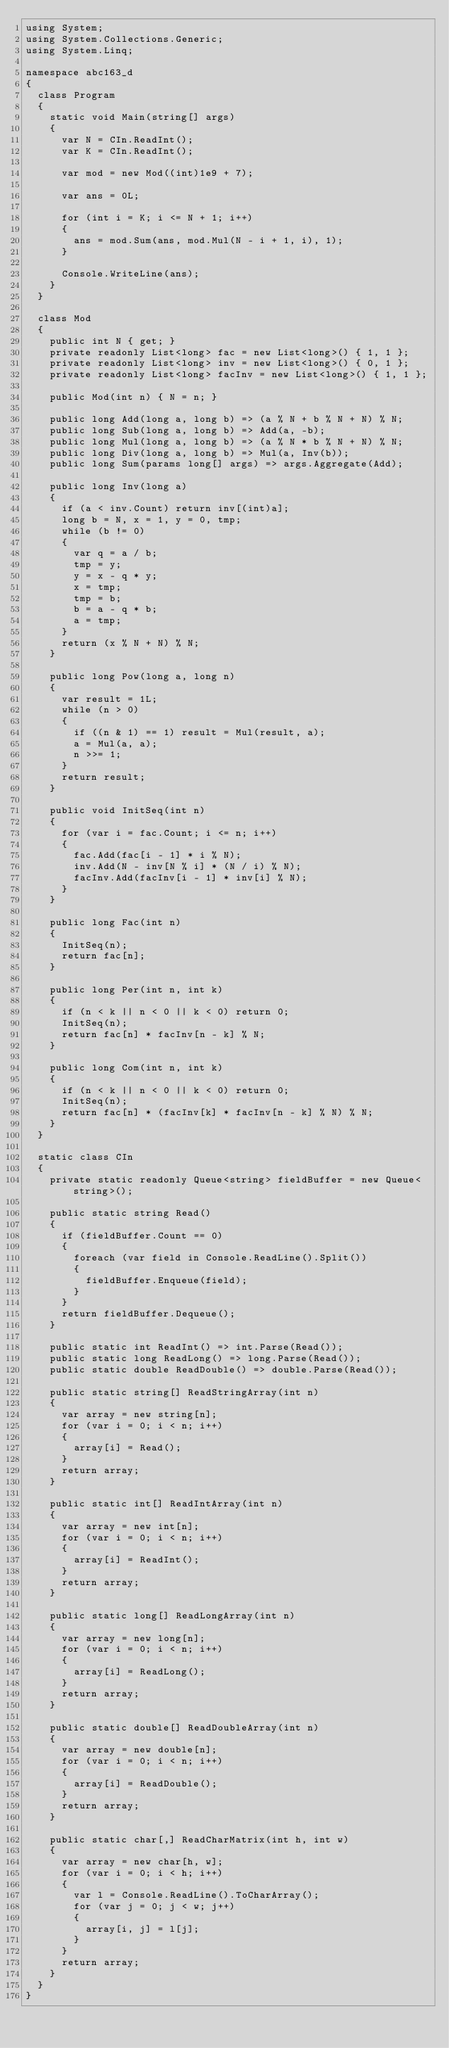Convert code to text. <code><loc_0><loc_0><loc_500><loc_500><_C#_>using System;
using System.Collections.Generic;
using System.Linq;

namespace abc163_d
{
  class Program
  {
    static void Main(string[] args)
    {
      var N = CIn.ReadInt();
      var K = CIn.ReadInt();

      var mod = new Mod((int)1e9 + 7);

      var ans = 0L;

      for (int i = K; i <= N + 1; i++)
      {
        ans = mod.Sum(ans, mod.Mul(N - i + 1, i), 1);
      }

      Console.WriteLine(ans);
    }
  }

  class Mod
  {
    public int N { get; }
    private readonly List<long> fac = new List<long>() { 1, 1 };
    private readonly List<long> inv = new List<long>() { 0, 1 };
    private readonly List<long> facInv = new List<long>() { 1, 1 };

    public Mod(int n) { N = n; }

    public long Add(long a, long b) => (a % N + b % N + N) % N;
    public long Sub(long a, long b) => Add(a, -b);
    public long Mul(long a, long b) => (a % N * b % N + N) % N;
    public long Div(long a, long b) => Mul(a, Inv(b));
    public long Sum(params long[] args) => args.Aggregate(Add);

    public long Inv(long a)
    {
      if (a < inv.Count) return inv[(int)a];
      long b = N, x = 1, y = 0, tmp;
      while (b != 0)
      {
        var q = a / b;
        tmp = y;
        y = x - q * y;
        x = tmp;
        tmp = b;
        b = a - q * b;
        a = tmp;
      }
      return (x % N + N) % N;
    }

    public long Pow(long a, long n)
    {
      var result = 1L;
      while (n > 0)
      {
        if ((n & 1) == 1) result = Mul(result, a);
        a = Mul(a, a);
        n >>= 1;
      }
      return result;
    }

    public void InitSeq(int n)
    {
      for (var i = fac.Count; i <= n; i++)
      {
        fac.Add(fac[i - 1] * i % N);
        inv.Add(N - inv[N % i] * (N / i) % N);
        facInv.Add(facInv[i - 1] * inv[i] % N);
      }
    }

    public long Fac(int n)
    {
      InitSeq(n);
      return fac[n];
    }

    public long Per(int n, int k)
    {
      if (n < k || n < 0 || k < 0) return 0;
      InitSeq(n);
      return fac[n] * facInv[n - k] % N;
    }

    public long Com(int n, int k)
    {
      if (n < k || n < 0 || k < 0) return 0;
      InitSeq(n);
      return fac[n] * (facInv[k] * facInv[n - k] % N) % N;
    }
  }

  static class CIn
  {
    private static readonly Queue<string> fieldBuffer = new Queue<string>();

    public static string Read()
    {
      if (fieldBuffer.Count == 0)
      {
        foreach (var field in Console.ReadLine().Split())
        {
          fieldBuffer.Enqueue(field);
        }
      }
      return fieldBuffer.Dequeue();
    }

    public static int ReadInt() => int.Parse(Read());
    public static long ReadLong() => long.Parse(Read());
    public static double ReadDouble() => double.Parse(Read());

    public static string[] ReadStringArray(int n)
    {
      var array = new string[n];
      for (var i = 0; i < n; i++)
      {
        array[i] = Read();
      }
      return array;
    }

    public static int[] ReadIntArray(int n)
    {
      var array = new int[n];
      for (var i = 0; i < n; i++)
      {
        array[i] = ReadInt();
      }
      return array;
    }

    public static long[] ReadLongArray(int n)
    {
      var array = new long[n];
      for (var i = 0; i < n; i++)
      {
        array[i] = ReadLong();
      }
      return array;
    }

    public static double[] ReadDoubleArray(int n)
    {
      var array = new double[n];
      for (var i = 0; i < n; i++)
      {
        array[i] = ReadDouble();
      }
      return array;
    }

    public static char[,] ReadCharMatrix(int h, int w)
    {
      var array = new char[h, w];
      for (var i = 0; i < h; i++)
      {
        var l = Console.ReadLine().ToCharArray();
        for (var j = 0; j < w; j++)
        {
          array[i, j] = l[j];
        }
      }
      return array;
    }
  }
}
</code> 